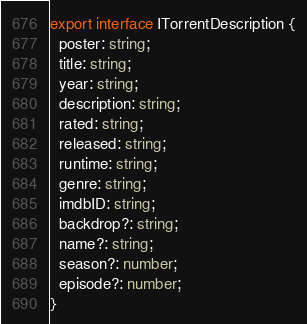Convert code to text. <code><loc_0><loc_0><loc_500><loc_500><_TypeScript_>export interface ITorrentDescription {
  poster: string;
  title: string;
  year: string;
  description: string;
  rated: string;
  released: string;
  runtime: string;
  genre: string;
  imdbID: string;
  backdrop?: string;
  name?: string;
  season?: number;
  episode?: number;
}
</code> 